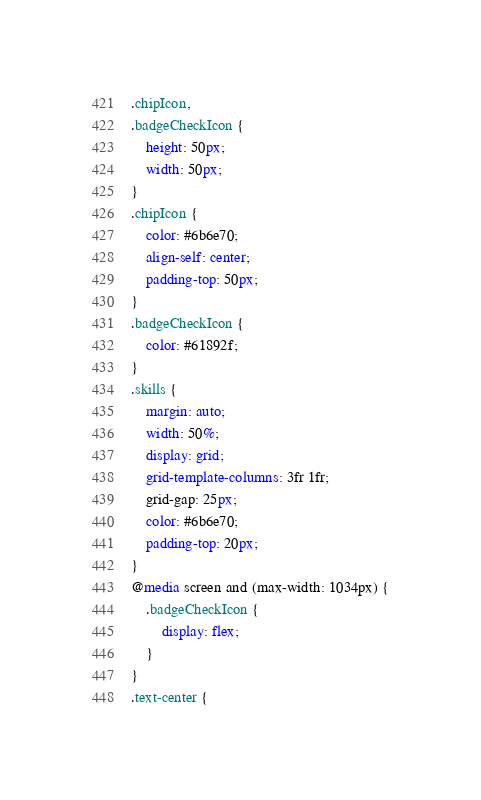<code> <loc_0><loc_0><loc_500><loc_500><_CSS_>.chipIcon,
.badgeCheckIcon {
    height: 50px;
    width: 50px;
}
.chipIcon {
    color: #6b6e70;
    align-self: center;
    padding-top: 50px;
}
.badgeCheckIcon {
    color: #61892f;
}
.skills {
    margin: auto;
    width: 50%;
    display: grid;
    grid-template-columns: 3fr 1fr;
    grid-gap: 25px;
    color: #6b6e70;
    padding-top: 20px;
}
@media screen and (max-width: 1034px) {
    .badgeCheckIcon {
        display: flex;
    }
}
.text-center {</code> 